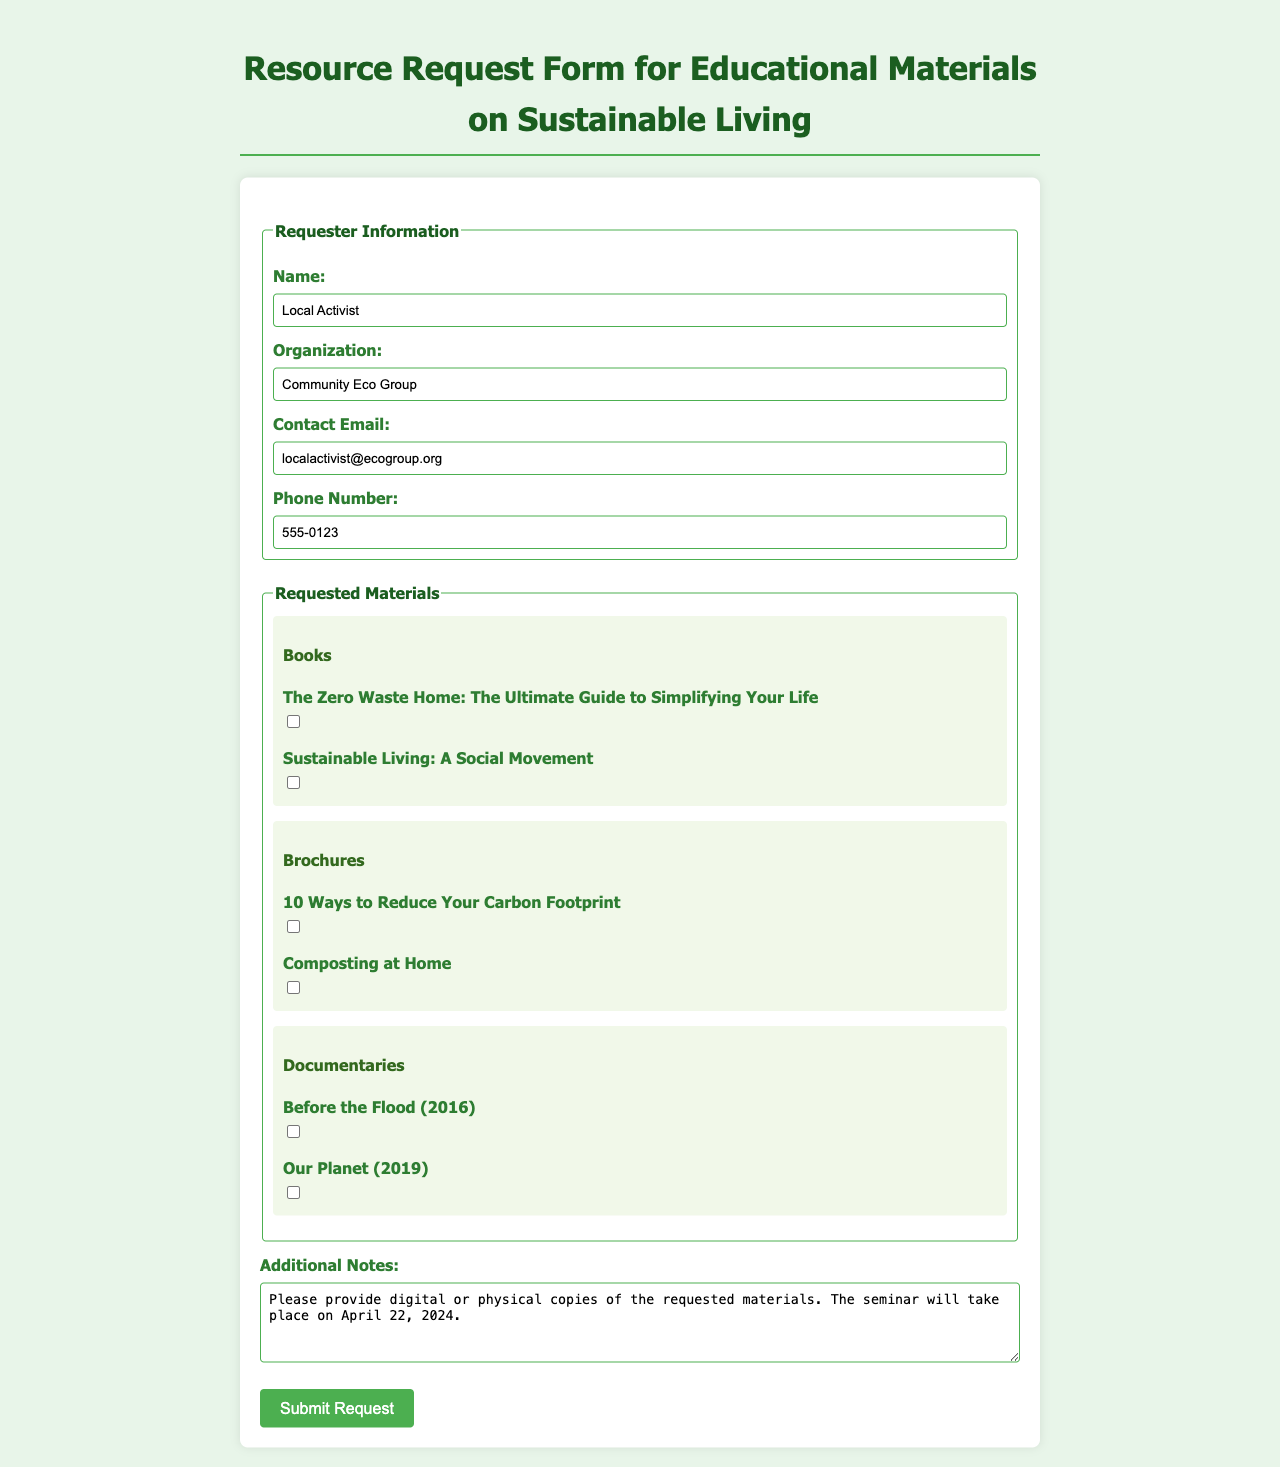What is the name of the requester? The requester's name is located in the "Requester Information" section of the form.
Answer: Local Activist What organization is the requester affiliated with? The organization name can be found directly under the requester's name in the "Requester Information" section.
Answer: Community Eco Group What type of materials are being requested? The types of materials can be identified in the "Requested Materials" section, where different categories are presented.
Answer: Books, Brochures, Documentaries What is the contact email for the requester? The contact email is listed in the "Requester Information" section of the form.
Answer: localactivist@ecogroup.org What is the date of the seminar? The date is mentioned in the "Additional Notes" section of the form.
Answer: April 22, 2024 How many books are requested? The number of books can be determined by counting the checkboxes under the "Books" category in the "Requested Materials" section.
Answer: 2 Name one documentary requested. The requested documentaries can be found under the "Documentaries" category within the "Requested Materials" section; one example is provided.
Answer: Before the Flood What is the phone number of the requester? The phone number is included in the "Requester Information" section for contact purposes.
Answer: 555-0123 What type of notes can be found under "Additional Notes"? The "Additional Notes" section contains a space where the requester can provide specific instructions or requests regarding the materials.
Answer: Request for digital or physical copies 